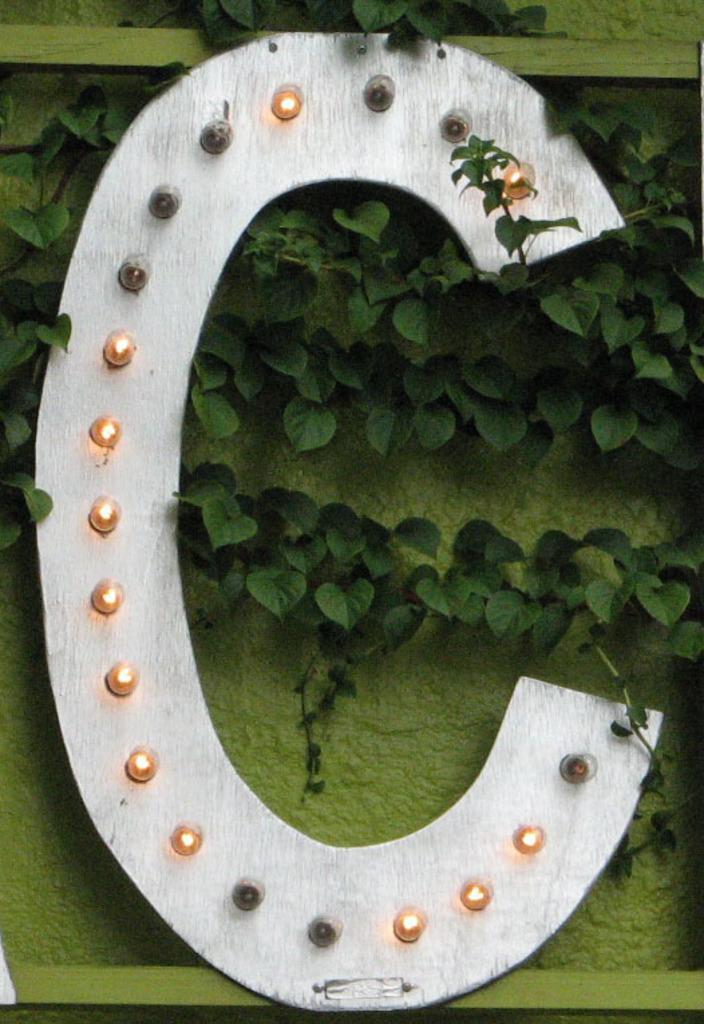Can you describe this image briefly? As we can see in the image there is a wall, leaves and lights. 